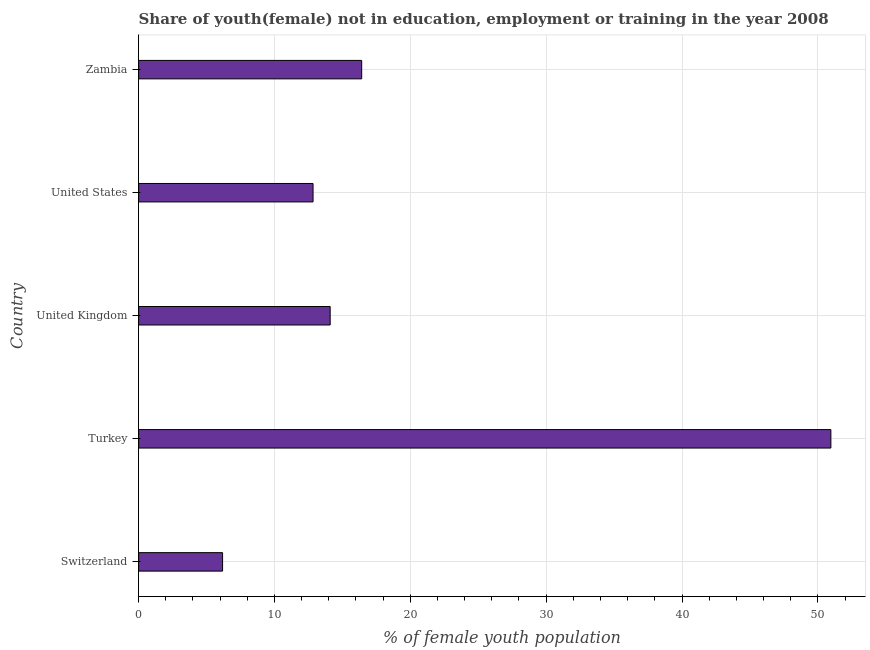Does the graph contain any zero values?
Offer a terse response. No. Does the graph contain grids?
Provide a short and direct response. Yes. What is the title of the graph?
Your answer should be compact. Share of youth(female) not in education, employment or training in the year 2008. What is the label or title of the X-axis?
Offer a very short reply. % of female youth population. What is the label or title of the Y-axis?
Make the answer very short. Country. What is the unemployed female youth population in Turkey?
Provide a short and direct response. 50.96. Across all countries, what is the maximum unemployed female youth population?
Your response must be concise. 50.96. Across all countries, what is the minimum unemployed female youth population?
Your answer should be compact. 6.18. In which country was the unemployed female youth population maximum?
Your response must be concise. Turkey. In which country was the unemployed female youth population minimum?
Your answer should be very brief. Switzerland. What is the sum of the unemployed female youth population?
Make the answer very short. 100.5. What is the difference between the unemployed female youth population in Switzerland and United Kingdom?
Make the answer very short. -7.92. What is the average unemployed female youth population per country?
Make the answer very short. 20.1. What is the median unemployed female youth population?
Offer a terse response. 14.1. What is the ratio of the unemployed female youth population in United States to that in Zambia?
Ensure brevity in your answer.  0.78. Is the unemployed female youth population in United Kingdom less than that in Zambia?
Offer a very short reply. Yes. Is the difference between the unemployed female youth population in Switzerland and Turkey greater than the difference between any two countries?
Offer a terse response. Yes. What is the difference between the highest and the second highest unemployed female youth population?
Offer a terse response. 34.54. Is the sum of the unemployed female youth population in Switzerland and Zambia greater than the maximum unemployed female youth population across all countries?
Your response must be concise. No. What is the difference between the highest and the lowest unemployed female youth population?
Your answer should be compact. 44.78. How many bars are there?
Provide a succinct answer. 5. Are the values on the major ticks of X-axis written in scientific E-notation?
Make the answer very short. No. What is the % of female youth population of Switzerland?
Offer a very short reply. 6.18. What is the % of female youth population of Turkey?
Offer a very short reply. 50.96. What is the % of female youth population in United Kingdom?
Make the answer very short. 14.1. What is the % of female youth population in United States?
Offer a very short reply. 12.84. What is the % of female youth population of Zambia?
Your answer should be compact. 16.42. What is the difference between the % of female youth population in Switzerland and Turkey?
Keep it short and to the point. -44.78. What is the difference between the % of female youth population in Switzerland and United Kingdom?
Make the answer very short. -7.92. What is the difference between the % of female youth population in Switzerland and United States?
Offer a very short reply. -6.66. What is the difference between the % of female youth population in Switzerland and Zambia?
Offer a very short reply. -10.24. What is the difference between the % of female youth population in Turkey and United Kingdom?
Your response must be concise. 36.86. What is the difference between the % of female youth population in Turkey and United States?
Make the answer very short. 38.12. What is the difference between the % of female youth population in Turkey and Zambia?
Your answer should be compact. 34.54. What is the difference between the % of female youth population in United Kingdom and United States?
Offer a terse response. 1.26. What is the difference between the % of female youth population in United Kingdom and Zambia?
Make the answer very short. -2.32. What is the difference between the % of female youth population in United States and Zambia?
Give a very brief answer. -3.58. What is the ratio of the % of female youth population in Switzerland to that in Turkey?
Offer a terse response. 0.12. What is the ratio of the % of female youth population in Switzerland to that in United Kingdom?
Ensure brevity in your answer.  0.44. What is the ratio of the % of female youth population in Switzerland to that in United States?
Make the answer very short. 0.48. What is the ratio of the % of female youth population in Switzerland to that in Zambia?
Make the answer very short. 0.38. What is the ratio of the % of female youth population in Turkey to that in United Kingdom?
Give a very brief answer. 3.61. What is the ratio of the % of female youth population in Turkey to that in United States?
Your response must be concise. 3.97. What is the ratio of the % of female youth population in Turkey to that in Zambia?
Offer a terse response. 3.1. What is the ratio of the % of female youth population in United Kingdom to that in United States?
Your answer should be compact. 1.1. What is the ratio of the % of female youth population in United Kingdom to that in Zambia?
Ensure brevity in your answer.  0.86. What is the ratio of the % of female youth population in United States to that in Zambia?
Offer a terse response. 0.78. 